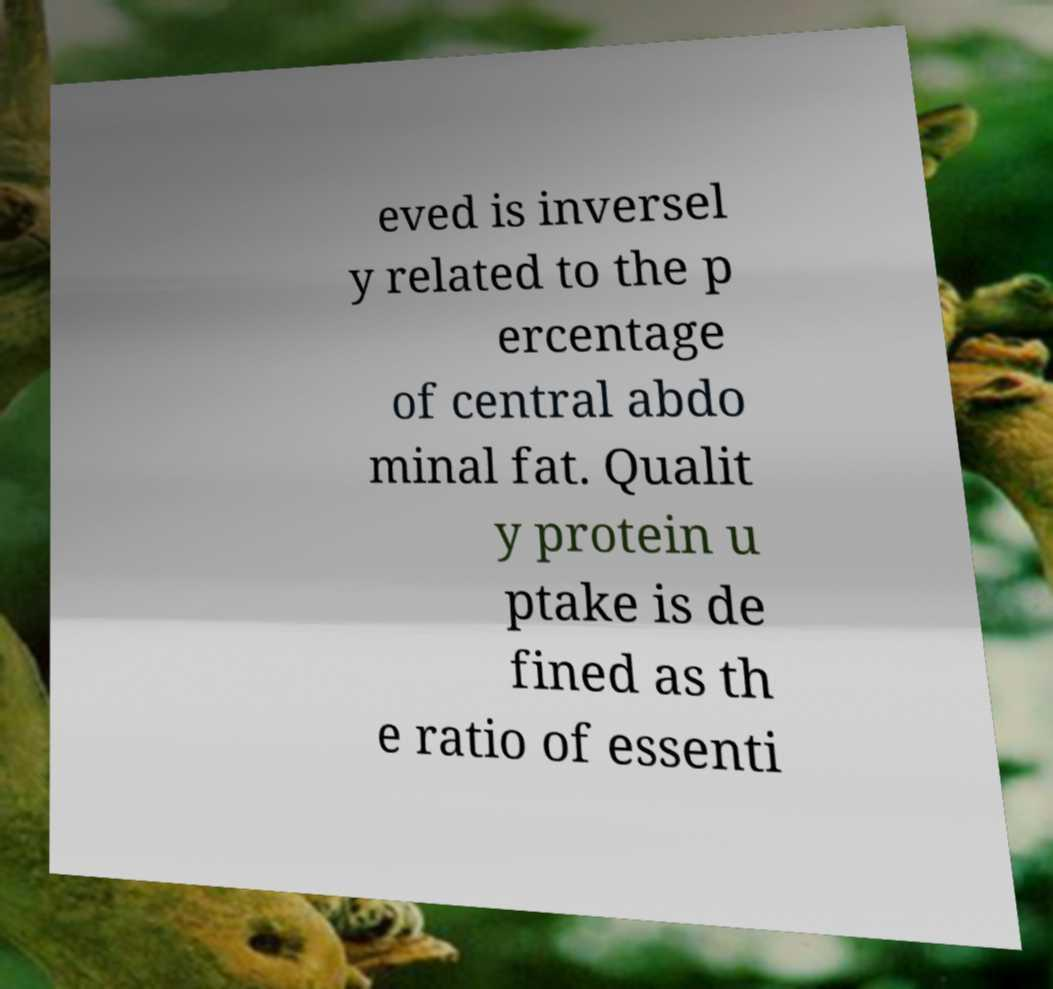Could you assist in decoding the text presented in this image and type it out clearly? eved is inversel y related to the p ercentage of central abdo minal fat. Qualit y protein u ptake is de fined as th e ratio of essenti 